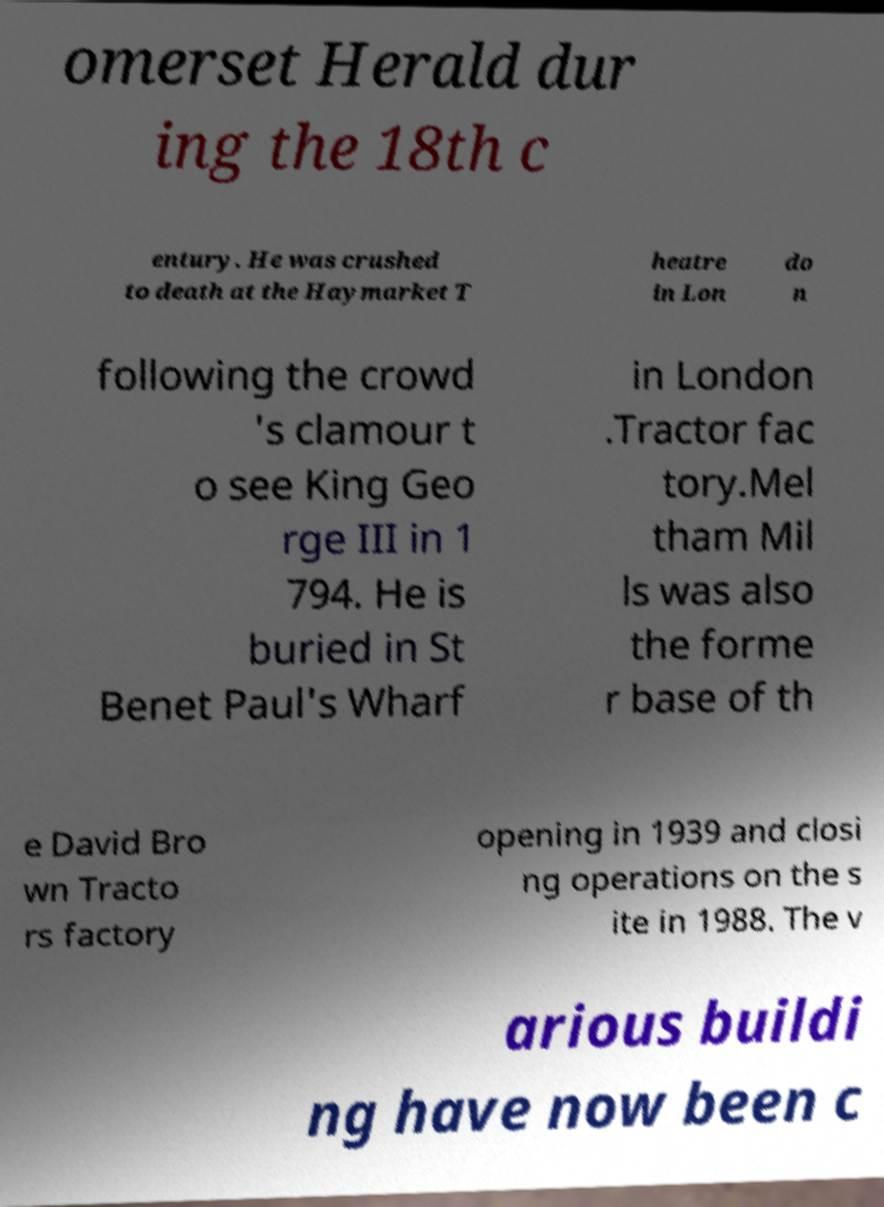There's text embedded in this image that I need extracted. Can you transcribe it verbatim? omerset Herald dur ing the 18th c entury. He was crushed to death at the Haymarket T heatre in Lon do n following the crowd 's clamour t o see King Geo rge III in 1 794. He is buried in St Benet Paul's Wharf in London .Tractor fac tory.Mel tham Mil ls was also the forme r base of th e David Bro wn Tracto rs factory opening in 1939 and closi ng operations on the s ite in 1988. The v arious buildi ng have now been c 